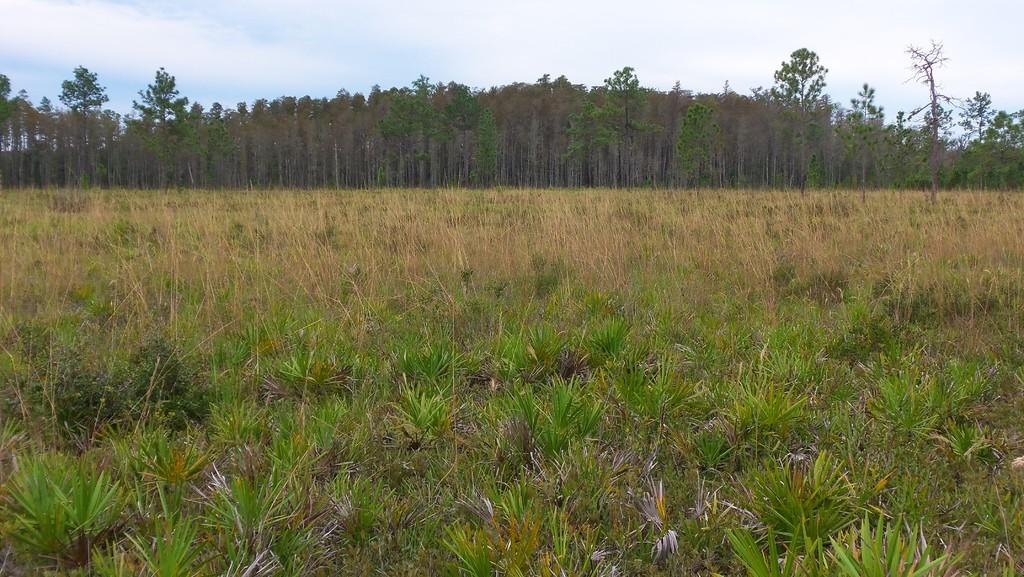What type of vegetation can be seen in the image? There are plants and grass in the image. What can be seen in the background of the image? There are trees and the sky in the background of the image. How would you describe the sky in the image? The sky is clear and visible in the background of the image. What type of curtain can be seen hanging from the trees in the image? There are no curtains present in the image; it features plants, grass, trees, and a clear sky. 